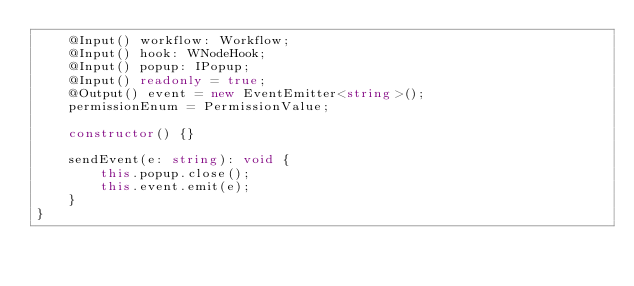<code> <loc_0><loc_0><loc_500><loc_500><_TypeScript_>    @Input() workflow: Workflow;
    @Input() hook: WNodeHook;
    @Input() popup: IPopup;
    @Input() readonly = true;
    @Output() event = new EventEmitter<string>();
    permissionEnum = PermissionValue;

    constructor() {}

    sendEvent(e: string): void {
        this.popup.close();
        this.event.emit(e);
    }
}
</code> 